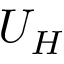<formula> <loc_0><loc_0><loc_500><loc_500>U _ { H }</formula> 